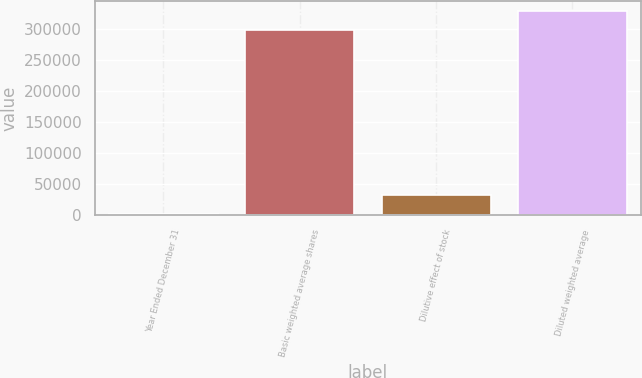Convert chart to OTSL. <chart><loc_0><loc_0><loc_500><loc_500><bar_chart><fcel>Year Ended December 31<fcel>Basic weighted average shares<fcel>Dilutive effect of stock<fcel>Diluted weighted average<nl><fcel>2017<fcel>299172<fcel>32279<fcel>329434<nl></chart> 